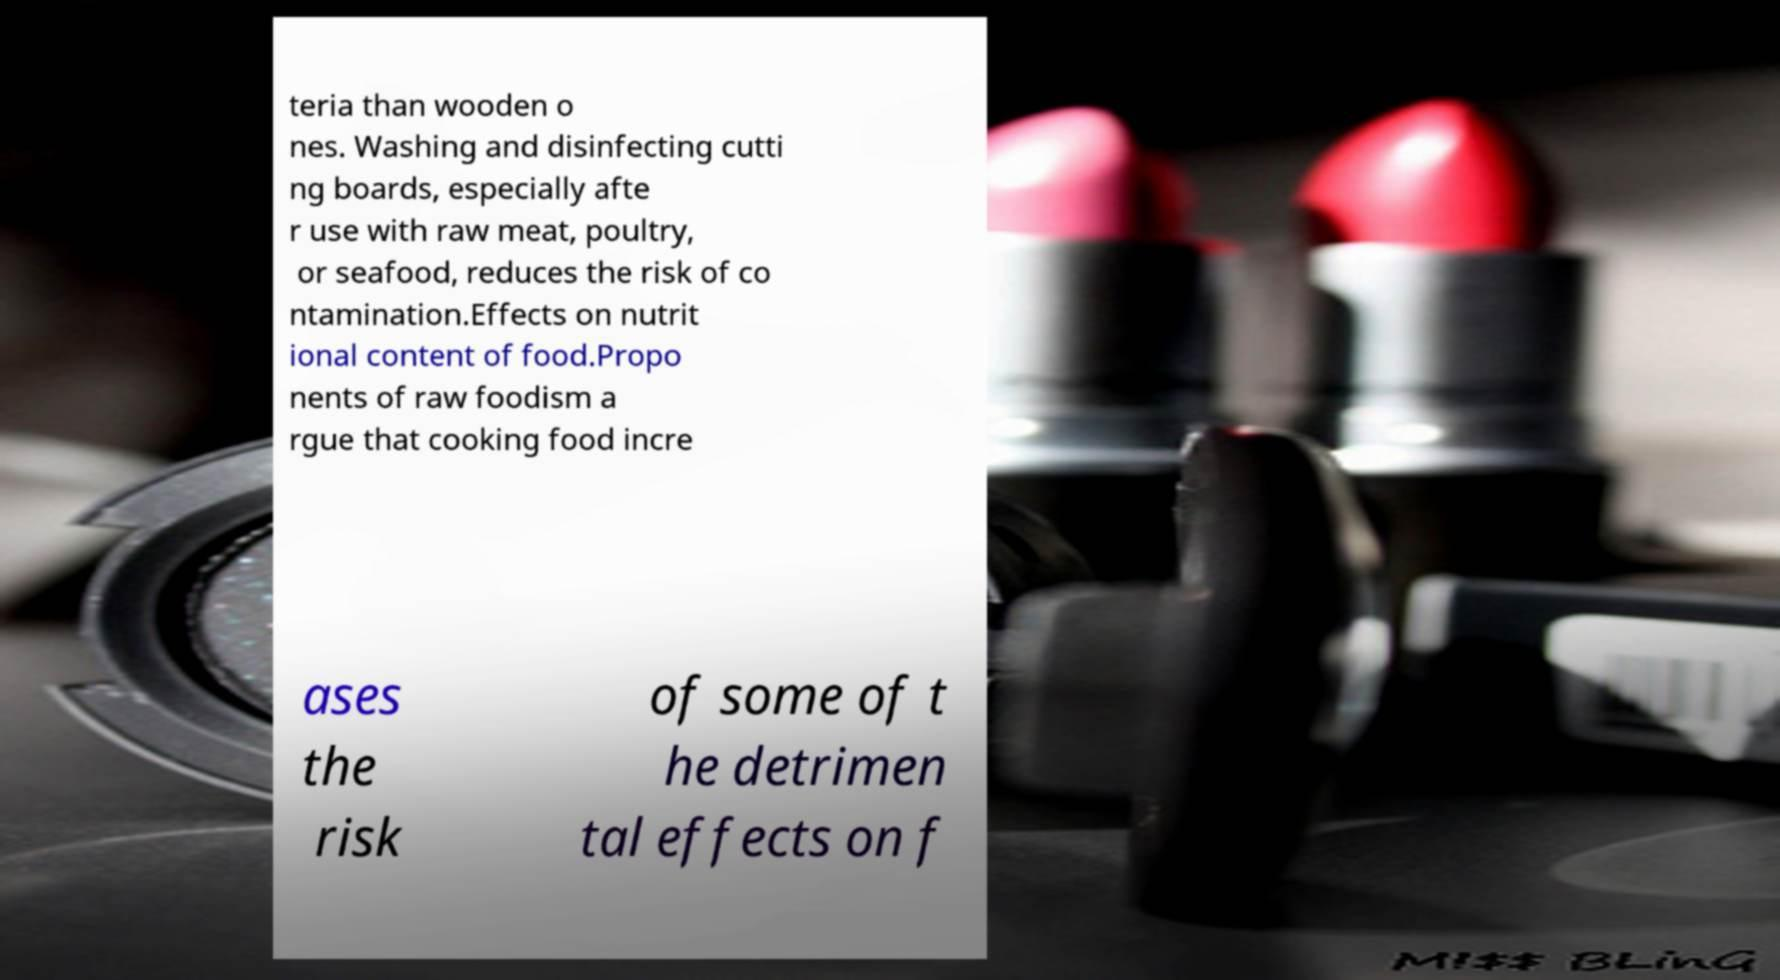Please identify and transcribe the text found in this image. teria than wooden o nes. Washing and disinfecting cutti ng boards, especially afte r use with raw meat, poultry, or seafood, reduces the risk of co ntamination.Effects on nutrit ional content of food.Propo nents of raw foodism a rgue that cooking food incre ases the risk of some of t he detrimen tal effects on f 